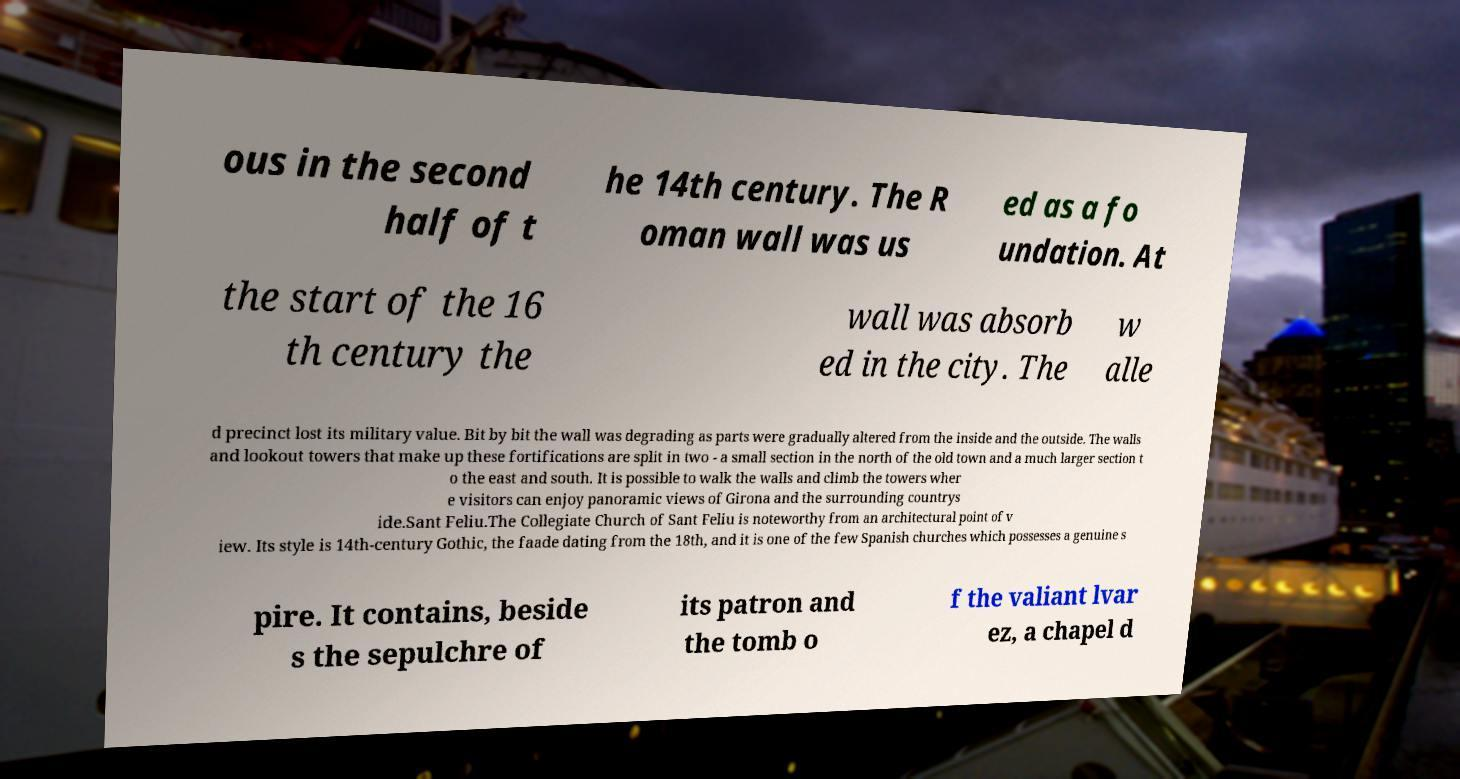I need the written content from this picture converted into text. Can you do that? ous in the second half of t he 14th century. The R oman wall was us ed as a fo undation. At the start of the 16 th century the wall was absorb ed in the city. The w alle d precinct lost its military value. Bit by bit the wall was degrading as parts were gradually altered from the inside and the outside. The walls and lookout towers that make up these fortifications are split in two - a small section in the north of the old town and a much larger section t o the east and south. It is possible to walk the walls and climb the towers wher e visitors can enjoy panoramic views of Girona and the surrounding countrys ide.Sant Feliu.The Collegiate Church of Sant Feliu is noteworthy from an architectural point of v iew. Its style is 14th-century Gothic, the faade dating from the 18th, and it is one of the few Spanish churches which possesses a genuine s pire. It contains, beside s the sepulchre of its patron and the tomb o f the valiant lvar ez, a chapel d 